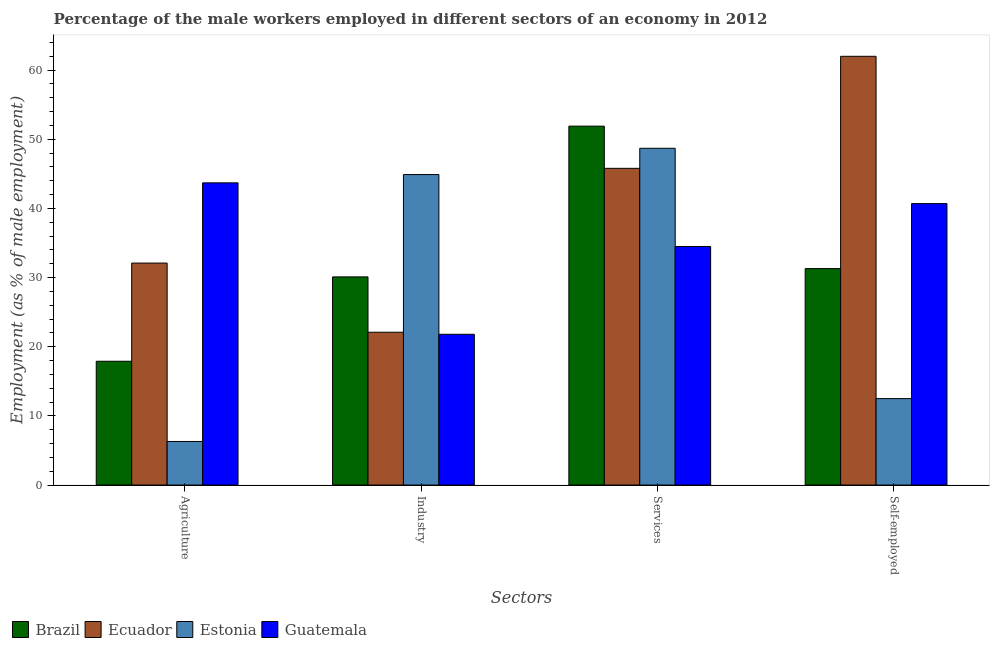How many groups of bars are there?
Keep it short and to the point. 4. Are the number of bars on each tick of the X-axis equal?
Your answer should be very brief. Yes. How many bars are there on the 1st tick from the left?
Offer a terse response. 4. How many bars are there on the 2nd tick from the right?
Keep it short and to the point. 4. What is the label of the 1st group of bars from the left?
Your answer should be very brief. Agriculture. What is the percentage of male workers in agriculture in Guatemala?
Offer a terse response. 43.7. Across all countries, what is the minimum percentage of self employed male workers?
Your answer should be compact. 12.5. In which country was the percentage of male workers in agriculture maximum?
Provide a short and direct response. Guatemala. In which country was the percentage of male workers in services minimum?
Ensure brevity in your answer.  Guatemala. What is the total percentage of self employed male workers in the graph?
Provide a short and direct response. 146.5. What is the difference between the percentage of self employed male workers in Brazil and that in Estonia?
Your answer should be compact. 18.8. What is the difference between the percentage of male workers in agriculture in Guatemala and the percentage of self employed male workers in Ecuador?
Your answer should be very brief. -18.3. What is the average percentage of male workers in industry per country?
Offer a terse response. 29.73. What is the difference between the percentage of male workers in agriculture and percentage of male workers in services in Guatemala?
Give a very brief answer. 9.2. In how many countries, is the percentage of male workers in industry greater than 30 %?
Provide a succinct answer. 2. What is the ratio of the percentage of male workers in industry in Estonia to that in Ecuador?
Your answer should be compact. 2.03. Is the percentage of male workers in industry in Brazil less than that in Estonia?
Your response must be concise. Yes. Is the difference between the percentage of male workers in industry in Ecuador and Guatemala greater than the difference between the percentage of male workers in services in Ecuador and Guatemala?
Your answer should be very brief. No. What is the difference between the highest and the second highest percentage of male workers in services?
Make the answer very short. 3.2. What is the difference between the highest and the lowest percentage of male workers in industry?
Your answer should be compact. 23.1. Is the sum of the percentage of male workers in industry in Estonia and Brazil greater than the maximum percentage of male workers in services across all countries?
Ensure brevity in your answer.  Yes. What does the 1st bar from the left in Services represents?
Your response must be concise. Brazil. What does the 4th bar from the right in Agriculture represents?
Provide a short and direct response. Brazil. Is it the case that in every country, the sum of the percentage of male workers in agriculture and percentage of male workers in industry is greater than the percentage of male workers in services?
Provide a succinct answer. No. Are all the bars in the graph horizontal?
Give a very brief answer. No. What is the difference between two consecutive major ticks on the Y-axis?
Your answer should be compact. 10. Where does the legend appear in the graph?
Your answer should be very brief. Bottom left. How are the legend labels stacked?
Provide a short and direct response. Horizontal. What is the title of the graph?
Your response must be concise. Percentage of the male workers employed in different sectors of an economy in 2012. What is the label or title of the X-axis?
Keep it short and to the point. Sectors. What is the label or title of the Y-axis?
Keep it short and to the point. Employment (as % of male employment). What is the Employment (as % of male employment) of Brazil in Agriculture?
Offer a terse response. 17.9. What is the Employment (as % of male employment) of Ecuador in Agriculture?
Your response must be concise. 32.1. What is the Employment (as % of male employment) in Estonia in Agriculture?
Make the answer very short. 6.3. What is the Employment (as % of male employment) in Guatemala in Agriculture?
Provide a succinct answer. 43.7. What is the Employment (as % of male employment) of Brazil in Industry?
Your answer should be compact. 30.1. What is the Employment (as % of male employment) of Ecuador in Industry?
Offer a very short reply. 22.1. What is the Employment (as % of male employment) in Estonia in Industry?
Your response must be concise. 44.9. What is the Employment (as % of male employment) of Guatemala in Industry?
Give a very brief answer. 21.8. What is the Employment (as % of male employment) in Brazil in Services?
Make the answer very short. 51.9. What is the Employment (as % of male employment) in Ecuador in Services?
Keep it short and to the point. 45.8. What is the Employment (as % of male employment) in Estonia in Services?
Make the answer very short. 48.7. What is the Employment (as % of male employment) of Guatemala in Services?
Give a very brief answer. 34.5. What is the Employment (as % of male employment) of Brazil in Self-employed?
Offer a very short reply. 31.3. What is the Employment (as % of male employment) in Ecuador in Self-employed?
Offer a terse response. 62. What is the Employment (as % of male employment) in Estonia in Self-employed?
Ensure brevity in your answer.  12.5. What is the Employment (as % of male employment) of Guatemala in Self-employed?
Offer a very short reply. 40.7. Across all Sectors, what is the maximum Employment (as % of male employment) of Brazil?
Keep it short and to the point. 51.9. Across all Sectors, what is the maximum Employment (as % of male employment) of Estonia?
Your response must be concise. 48.7. Across all Sectors, what is the maximum Employment (as % of male employment) of Guatemala?
Offer a very short reply. 43.7. Across all Sectors, what is the minimum Employment (as % of male employment) of Brazil?
Offer a very short reply. 17.9. Across all Sectors, what is the minimum Employment (as % of male employment) of Ecuador?
Your response must be concise. 22.1. Across all Sectors, what is the minimum Employment (as % of male employment) in Estonia?
Make the answer very short. 6.3. Across all Sectors, what is the minimum Employment (as % of male employment) in Guatemala?
Make the answer very short. 21.8. What is the total Employment (as % of male employment) of Brazil in the graph?
Provide a short and direct response. 131.2. What is the total Employment (as % of male employment) in Ecuador in the graph?
Ensure brevity in your answer.  162. What is the total Employment (as % of male employment) in Estonia in the graph?
Your answer should be compact. 112.4. What is the total Employment (as % of male employment) of Guatemala in the graph?
Your answer should be compact. 140.7. What is the difference between the Employment (as % of male employment) of Estonia in Agriculture and that in Industry?
Offer a terse response. -38.6. What is the difference between the Employment (as % of male employment) in Guatemala in Agriculture and that in Industry?
Your answer should be very brief. 21.9. What is the difference between the Employment (as % of male employment) in Brazil in Agriculture and that in Services?
Ensure brevity in your answer.  -34. What is the difference between the Employment (as % of male employment) of Ecuador in Agriculture and that in Services?
Offer a terse response. -13.7. What is the difference between the Employment (as % of male employment) of Estonia in Agriculture and that in Services?
Ensure brevity in your answer.  -42.4. What is the difference between the Employment (as % of male employment) in Brazil in Agriculture and that in Self-employed?
Provide a short and direct response. -13.4. What is the difference between the Employment (as % of male employment) of Ecuador in Agriculture and that in Self-employed?
Provide a short and direct response. -29.9. What is the difference between the Employment (as % of male employment) of Estonia in Agriculture and that in Self-employed?
Your response must be concise. -6.2. What is the difference between the Employment (as % of male employment) in Brazil in Industry and that in Services?
Give a very brief answer. -21.8. What is the difference between the Employment (as % of male employment) in Ecuador in Industry and that in Services?
Offer a terse response. -23.7. What is the difference between the Employment (as % of male employment) of Estonia in Industry and that in Services?
Your answer should be very brief. -3.8. What is the difference between the Employment (as % of male employment) of Guatemala in Industry and that in Services?
Your response must be concise. -12.7. What is the difference between the Employment (as % of male employment) in Ecuador in Industry and that in Self-employed?
Your response must be concise. -39.9. What is the difference between the Employment (as % of male employment) of Estonia in Industry and that in Self-employed?
Keep it short and to the point. 32.4. What is the difference between the Employment (as % of male employment) in Guatemala in Industry and that in Self-employed?
Your response must be concise. -18.9. What is the difference between the Employment (as % of male employment) in Brazil in Services and that in Self-employed?
Offer a terse response. 20.6. What is the difference between the Employment (as % of male employment) of Ecuador in Services and that in Self-employed?
Offer a very short reply. -16.2. What is the difference between the Employment (as % of male employment) in Estonia in Services and that in Self-employed?
Make the answer very short. 36.2. What is the difference between the Employment (as % of male employment) of Brazil in Agriculture and the Employment (as % of male employment) of Ecuador in Industry?
Provide a short and direct response. -4.2. What is the difference between the Employment (as % of male employment) of Brazil in Agriculture and the Employment (as % of male employment) of Guatemala in Industry?
Keep it short and to the point. -3.9. What is the difference between the Employment (as % of male employment) in Ecuador in Agriculture and the Employment (as % of male employment) in Estonia in Industry?
Ensure brevity in your answer.  -12.8. What is the difference between the Employment (as % of male employment) in Estonia in Agriculture and the Employment (as % of male employment) in Guatemala in Industry?
Offer a very short reply. -15.5. What is the difference between the Employment (as % of male employment) in Brazil in Agriculture and the Employment (as % of male employment) in Ecuador in Services?
Your answer should be compact. -27.9. What is the difference between the Employment (as % of male employment) of Brazil in Agriculture and the Employment (as % of male employment) of Estonia in Services?
Your response must be concise. -30.8. What is the difference between the Employment (as % of male employment) of Brazil in Agriculture and the Employment (as % of male employment) of Guatemala in Services?
Give a very brief answer. -16.6. What is the difference between the Employment (as % of male employment) in Ecuador in Agriculture and the Employment (as % of male employment) in Estonia in Services?
Give a very brief answer. -16.6. What is the difference between the Employment (as % of male employment) in Ecuador in Agriculture and the Employment (as % of male employment) in Guatemala in Services?
Keep it short and to the point. -2.4. What is the difference between the Employment (as % of male employment) of Estonia in Agriculture and the Employment (as % of male employment) of Guatemala in Services?
Your answer should be very brief. -28.2. What is the difference between the Employment (as % of male employment) in Brazil in Agriculture and the Employment (as % of male employment) in Ecuador in Self-employed?
Provide a short and direct response. -44.1. What is the difference between the Employment (as % of male employment) of Brazil in Agriculture and the Employment (as % of male employment) of Guatemala in Self-employed?
Keep it short and to the point. -22.8. What is the difference between the Employment (as % of male employment) in Ecuador in Agriculture and the Employment (as % of male employment) in Estonia in Self-employed?
Your response must be concise. 19.6. What is the difference between the Employment (as % of male employment) of Estonia in Agriculture and the Employment (as % of male employment) of Guatemala in Self-employed?
Make the answer very short. -34.4. What is the difference between the Employment (as % of male employment) in Brazil in Industry and the Employment (as % of male employment) in Ecuador in Services?
Offer a very short reply. -15.7. What is the difference between the Employment (as % of male employment) in Brazil in Industry and the Employment (as % of male employment) in Estonia in Services?
Your answer should be very brief. -18.6. What is the difference between the Employment (as % of male employment) in Ecuador in Industry and the Employment (as % of male employment) in Estonia in Services?
Your answer should be very brief. -26.6. What is the difference between the Employment (as % of male employment) of Brazil in Industry and the Employment (as % of male employment) of Ecuador in Self-employed?
Ensure brevity in your answer.  -31.9. What is the difference between the Employment (as % of male employment) of Brazil in Industry and the Employment (as % of male employment) of Guatemala in Self-employed?
Your answer should be compact. -10.6. What is the difference between the Employment (as % of male employment) of Ecuador in Industry and the Employment (as % of male employment) of Estonia in Self-employed?
Your response must be concise. 9.6. What is the difference between the Employment (as % of male employment) in Ecuador in Industry and the Employment (as % of male employment) in Guatemala in Self-employed?
Offer a terse response. -18.6. What is the difference between the Employment (as % of male employment) of Brazil in Services and the Employment (as % of male employment) of Ecuador in Self-employed?
Give a very brief answer. -10.1. What is the difference between the Employment (as % of male employment) of Brazil in Services and the Employment (as % of male employment) of Estonia in Self-employed?
Give a very brief answer. 39.4. What is the difference between the Employment (as % of male employment) in Brazil in Services and the Employment (as % of male employment) in Guatemala in Self-employed?
Keep it short and to the point. 11.2. What is the difference between the Employment (as % of male employment) in Ecuador in Services and the Employment (as % of male employment) in Estonia in Self-employed?
Your answer should be very brief. 33.3. What is the difference between the Employment (as % of male employment) in Ecuador in Services and the Employment (as % of male employment) in Guatemala in Self-employed?
Your answer should be very brief. 5.1. What is the average Employment (as % of male employment) in Brazil per Sectors?
Offer a very short reply. 32.8. What is the average Employment (as % of male employment) of Ecuador per Sectors?
Ensure brevity in your answer.  40.5. What is the average Employment (as % of male employment) in Estonia per Sectors?
Ensure brevity in your answer.  28.1. What is the average Employment (as % of male employment) of Guatemala per Sectors?
Offer a very short reply. 35.17. What is the difference between the Employment (as % of male employment) in Brazil and Employment (as % of male employment) in Ecuador in Agriculture?
Provide a succinct answer. -14.2. What is the difference between the Employment (as % of male employment) of Brazil and Employment (as % of male employment) of Estonia in Agriculture?
Ensure brevity in your answer.  11.6. What is the difference between the Employment (as % of male employment) in Brazil and Employment (as % of male employment) in Guatemala in Agriculture?
Give a very brief answer. -25.8. What is the difference between the Employment (as % of male employment) in Ecuador and Employment (as % of male employment) in Estonia in Agriculture?
Your answer should be compact. 25.8. What is the difference between the Employment (as % of male employment) of Estonia and Employment (as % of male employment) of Guatemala in Agriculture?
Give a very brief answer. -37.4. What is the difference between the Employment (as % of male employment) of Brazil and Employment (as % of male employment) of Ecuador in Industry?
Provide a short and direct response. 8. What is the difference between the Employment (as % of male employment) in Brazil and Employment (as % of male employment) in Estonia in Industry?
Offer a terse response. -14.8. What is the difference between the Employment (as % of male employment) of Brazil and Employment (as % of male employment) of Guatemala in Industry?
Provide a succinct answer. 8.3. What is the difference between the Employment (as % of male employment) of Ecuador and Employment (as % of male employment) of Estonia in Industry?
Keep it short and to the point. -22.8. What is the difference between the Employment (as % of male employment) in Ecuador and Employment (as % of male employment) in Guatemala in Industry?
Provide a short and direct response. 0.3. What is the difference between the Employment (as % of male employment) of Estonia and Employment (as % of male employment) of Guatemala in Industry?
Provide a succinct answer. 23.1. What is the difference between the Employment (as % of male employment) in Brazil and Employment (as % of male employment) in Ecuador in Services?
Provide a short and direct response. 6.1. What is the difference between the Employment (as % of male employment) in Brazil and Employment (as % of male employment) in Guatemala in Services?
Ensure brevity in your answer.  17.4. What is the difference between the Employment (as % of male employment) of Ecuador and Employment (as % of male employment) of Estonia in Services?
Keep it short and to the point. -2.9. What is the difference between the Employment (as % of male employment) of Ecuador and Employment (as % of male employment) of Guatemala in Services?
Keep it short and to the point. 11.3. What is the difference between the Employment (as % of male employment) in Estonia and Employment (as % of male employment) in Guatemala in Services?
Give a very brief answer. 14.2. What is the difference between the Employment (as % of male employment) of Brazil and Employment (as % of male employment) of Ecuador in Self-employed?
Make the answer very short. -30.7. What is the difference between the Employment (as % of male employment) in Brazil and Employment (as % of male employment) in Estonia in Self-employed?
Provide a succinct answer. 18.8. What is the difference between the Employment (as % of male employment) of Ecuador and Employment (as % of male employment) of Estonia in Self-employed?
Your answer should be compact. 49.5. What is the difference between the Employment (as % of male employment) of Ecuador and Employment (as % of male employment) of Guatemala in Self-employed?
Give a very brief answer. 21.3. What is the difference between the Employment (as % of male employment) in Estonia and Employment (as % of male employment) in Guatemala in Self-employed?
Your answer should be compact. -28.2. What is the ratio of the Employment (as % of male employment) in Brazil in Agriculture to that in Industry?
Offer a terse response. 0.59. What is the ratio of the Employment (as % of male employment) of Ecuador in Agriculture to that in Industry?
Provide a short and direct response. 1.45. What is the ratio of the Employment (as % of male employment) in Estonia in Agriculture to that in Industry?
Offer a terse response. 0.14. What is the ratio of the Employment (as % of male employment) of Guatemala in Agriculture to that in Industry?
Offer a terse response. 2. What is the ratio of the Employment (as % of male employment) in Brazil in Agriculture to that in Services?
Your answer should be compact. 0.34. What is the ratio of the Employment (as % of male employment) in Ecuador in Agriculture to that in Services?
Make the answer very short. 0.7. What is the ratio of the Employment (as % of male employment) of Estonia in Agriculture to that in Services?
Ensure brevity in your answer.  0.13. What is the ratio of the Employment (as % of male employment) of Guatemala in Agriculture to that in Services?
Your response must be concise. 1.27. What is the ratio of the Employment (as % of male employment) in Brazil in Agriculture to that in Self-employed?
Keep it short and to the point. 0.57. What is the ratio of the Employment (as % of male employment) of Ecuador in Agriculture to that in Self-employed?
Your answer should be compact. 0.52. What is the ratio of the Employment (as % of male employment) of Estonia in Agriculture to that in Self-employed?
Provide a succinct answer. 0.5. What is the ratio of the Employment (as % of male employment) in Guatemala in Agriculture to that in Self-employed?
Provide a short and direct response. 1.07. What is the ratio of the Employment (as % of male employment) of Brazil in Industry to that in Services?
Provide a succinct answer. 0.58. What is the ratio of the Employment (as % of male employment) in Ecuador in Industry to that in Services?
Ensure brevity in your answer.  0.48. What is the ratio of the Employment (as % of male employment) of Estonia in Industry to that in Services?
Ensure brevity in your answer.  0.92. What is the ratio of the Employment (as % of male employment) of Guatemala in Industry to that in Services?
Make the answer very short. 0.63. What is the ratio of the Employment (as % of male employment) in Brazil in Industry to that in Self-employed?
Give a very brief answer. 0.96. What is the ratio of the Employment (as % of male employment) of Ecuador in Industry to that in Self-employed?
Provide a short and direct response. 0.36. What is the ratio of the Employment (as % of male employment) of Estonia in Industry to that in Self-employed?
Your answer should be compact. 3.59. What is the ratio of the Employment (as % of male employment) of Guatemala in Industry to that in Self-employed?
Your answer should be compact. 0.54. What is the ratio of the Employment (as % of male employment) in Brazil in Services to that in Self-employed?
Your answer should be compact. 1.66. What is the ratio of the Employment (as % of male employment) of Ecuador in Services to that in Self-employed?
Your answer should be very brief. 0.74. What is the ratio of the Employment (as % of male employment) of Estonia in Services to that in Self-employed?
Provide a succinct answer. 3.9. What is the ratio of the Employment (as % of male employment) in Guatemala in Services to that in Self-employed?
Your answer should be compact. 0.85. What is the difference between the highest and the second highest Employment (as % of male employment) in Brazil?
Provide a short and direct response. 20.6. What is the difference between the highest and the second highest Employment (as % of male employment) of Ecuador?
Your answer should be very brief. 16.2. What is the difference between the highest and the lowest Employment (as % of male employment) of Brazil?
Offer a terse response. 34. What is the difference between the highest and the lowest Employment (as % of male employment) in Ecuador?
Your answer should be compact. 39.9. What is the difference between the highest and the lowest Employment (as % of male employment) of Estonia?
Make the answer very short. 42.4. What is the difference between the highest and the lowest Employment (as % of male employment) of Guatemala?
Offer a terse response. 21.9. 